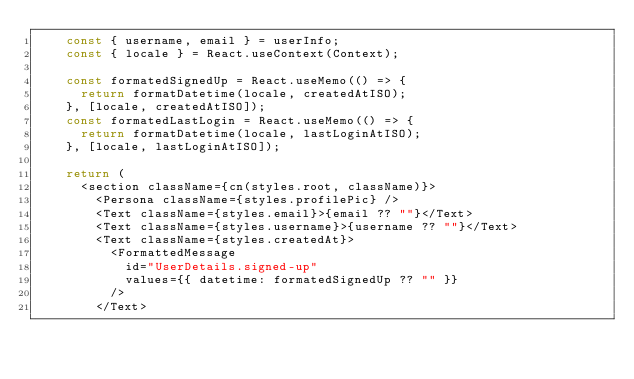<code> <loc_0><loc_0><loc_500><loc_500><_TypeScript_>    const { username, email } = userInfo;
    const { locale } = React.useContext(Context);

    const formatedSignedUp = React.useMemo(() => {
      return formatDatetime(locale, createdAtISO);
    }, [locale, createdAtISO]);
    const formatedLastLogin = React.useMemo(() => {
      return formatDatetime(locale, lastLoginAtISO);
    }, [locale, lastLoginAtISO]);

    return (
      <section className={cn(styles.root, className)}>
        <Persona className={styles.profilePic} />
        <Text className={styles.email}>{email ?? ""}</Text>
        <Text className={styles.username}>{username ?? ""}</Text>
        <Text className={styles.createdAt}>
          <FormattedMessage
            id="UserDetails.signed-up"
            values={{ datetime: formatedSignedUp ?? "" }}
          />
        </Text></code> 